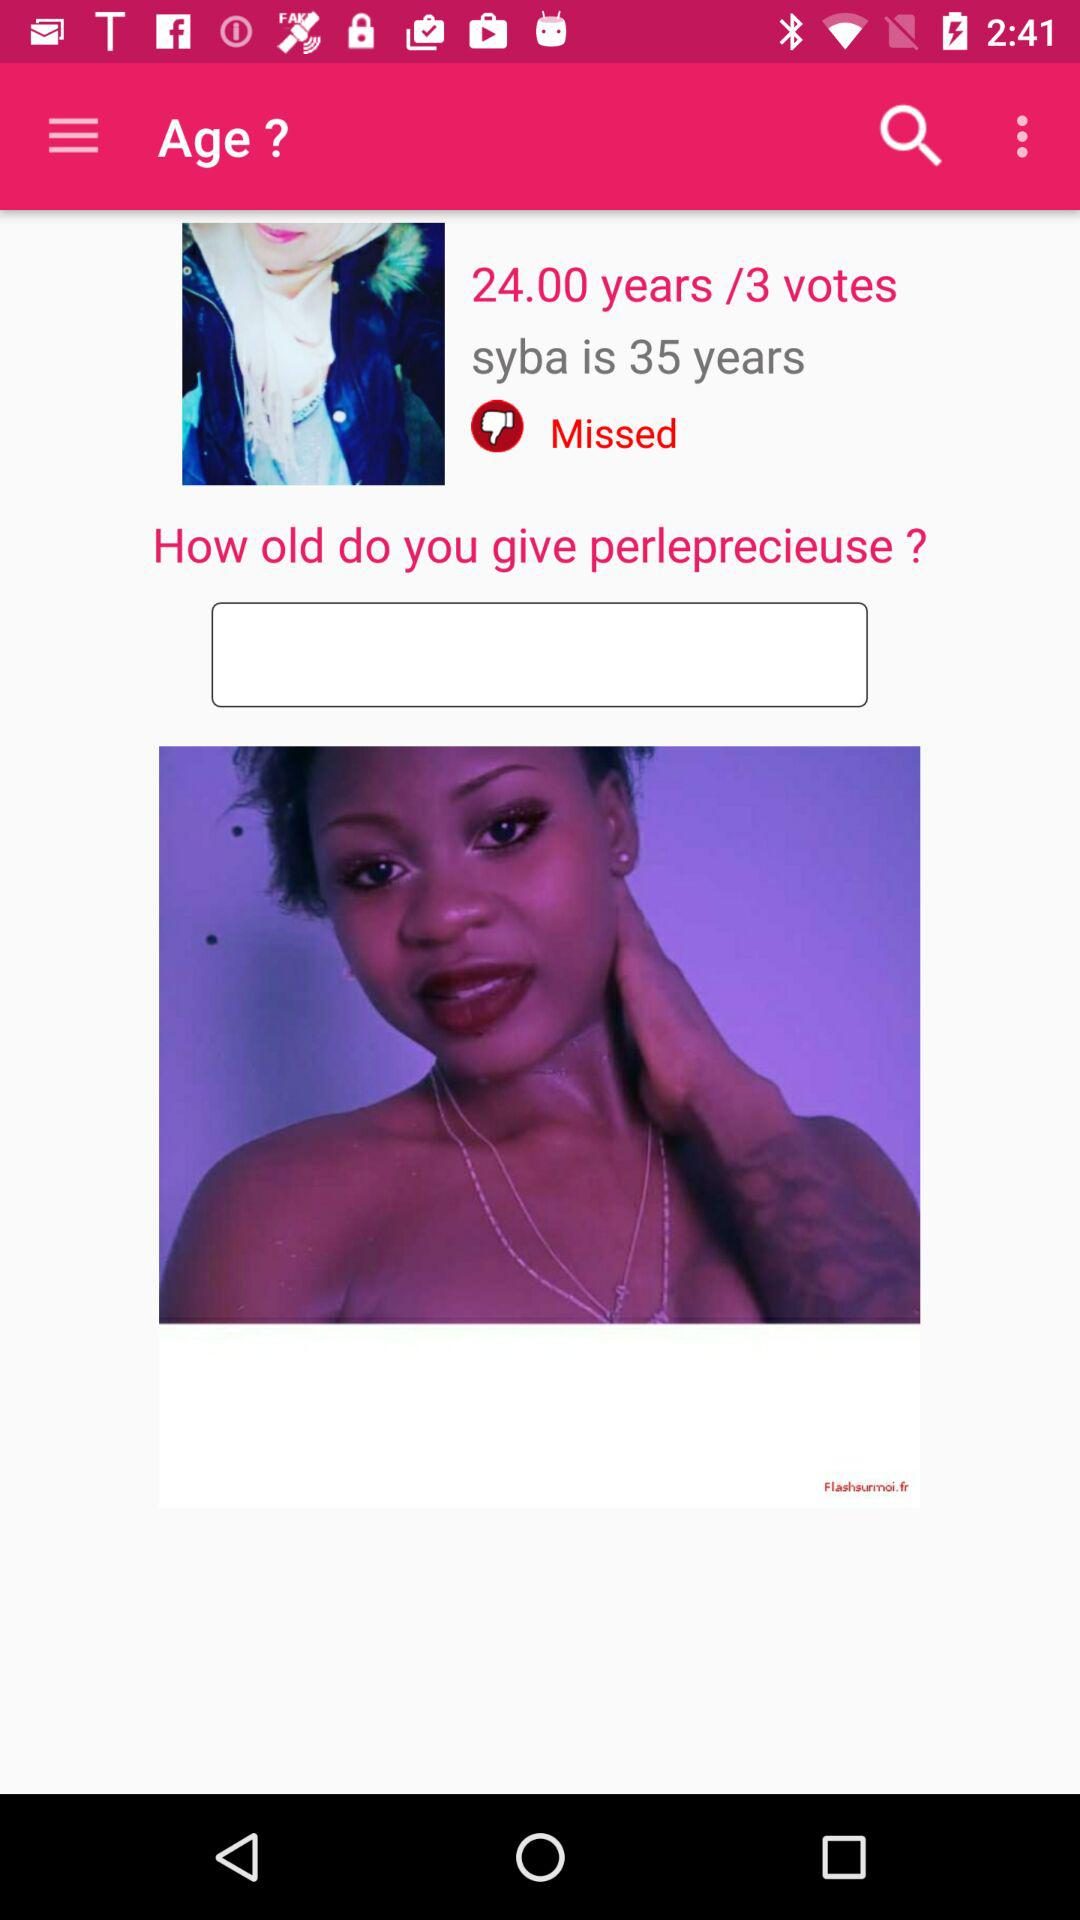What is the age of Syba? The age of Syba is 35 years old. 